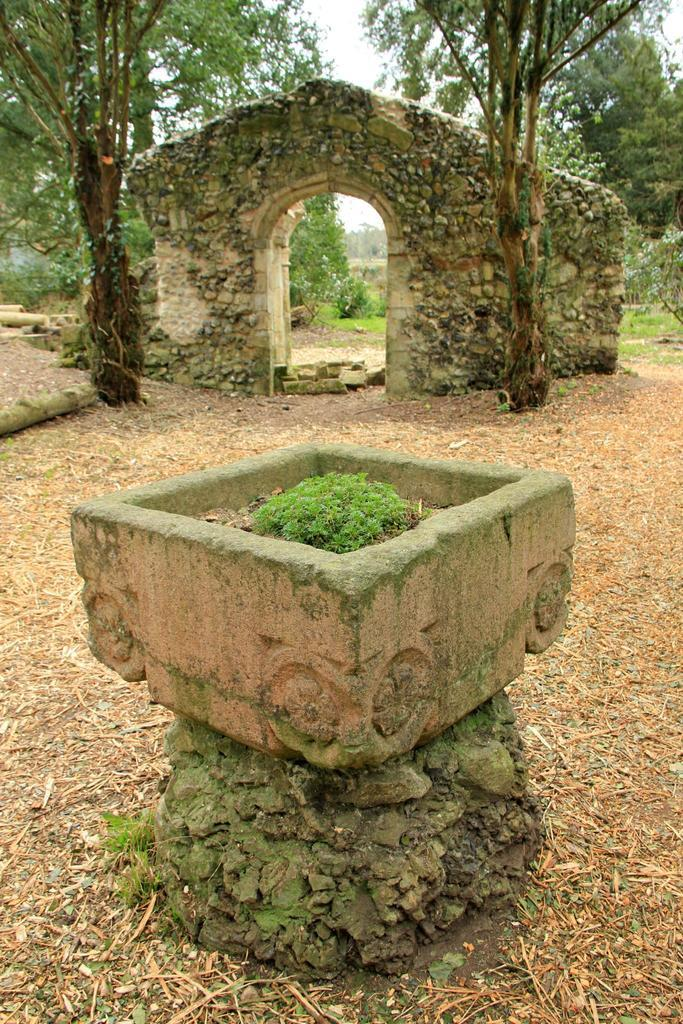What is the main object in the center of the image? There is a cement tub in the center of the image. What can be seen in the background of the image? There is an arch and trees in the background of the image. What type of coal is being used to create the smile on the cement tub? There is no coal or smile present on the cement tub in the image. 